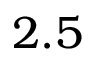Convert formula to latex. <formula><loc_0><loc_0><loc_500><loc_500>2 . 5</formula> 